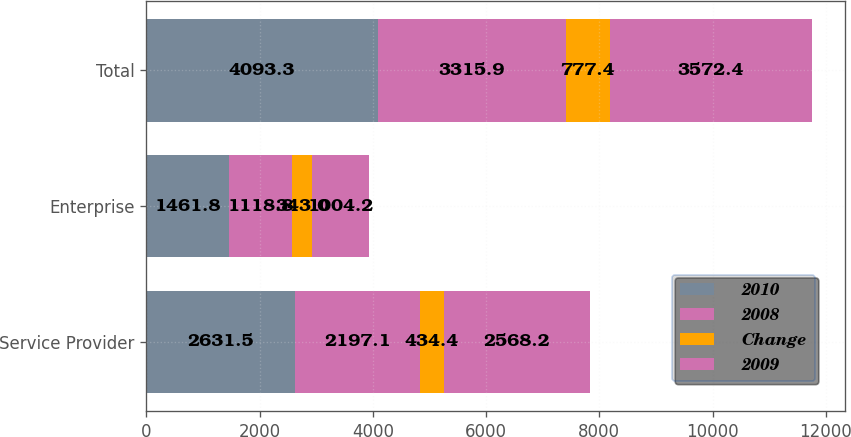<chart> <loc_0><loc_0><loc_500><loc_500><stacked_bar_chart><ecel><fcel>Service Provider<fcel>Enterprise<fcel>Total<nl><fcel>2010<fcel>2631.5<fcel>1461.8<fcel>4093.3<nl><fcel>2008<fcel>2197.1<fcel>1118.8<fcel>3315.9<nl><fcel>Change<fcel>434.4<fcel>343<fcel>777.4<nl><fcel>2009<fcel>2568.2<fcel>1004.2<fcel>3572.4<nl></chart> 